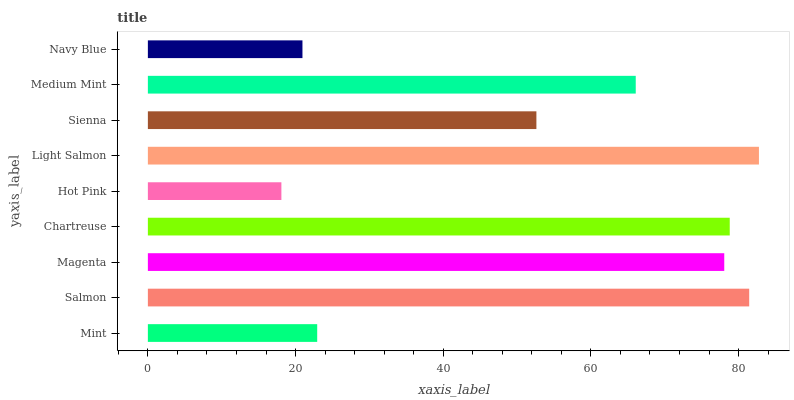Is Hot Pink the minimum?
Answer yes or no. Yes. Is Light Salmon the maximum?
Answer yes or no. Yes. Is Salmon the minimum?
Answer yes or no. No. Is Salmon the maximum?
Answer yes or no. No. Is Salmon greater than Mint?
Answer yes or no. Yes. Is Mint less than Salmon?
Answer yes or no. Yes. Is Mint greater than Salmon?
Answer yes or no. No. Is Salmon less than Mint?
Answer yes or no. No. Is Medium Mint the high median?
Answer yes or no. Yes. Is Medium Mint the low median?
Answer yes or no. Yes. Is Light Salmon the high median?
Answer yes or no. No. Is Navy Blue the low median?
Answer yes or no. No. 